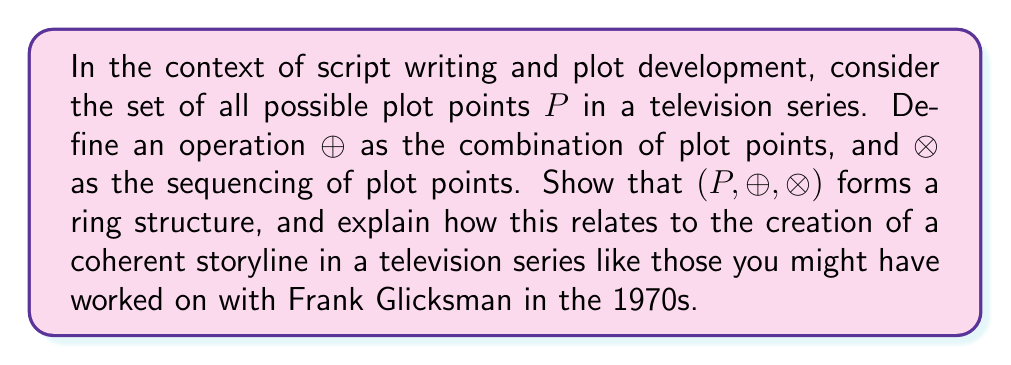What is the answer to this math problem? To show that $(P, \oplus, \otimes)$ forms a ring structure, we need to verify the following properties:

1. $(P, \oplus)$ is an abelian group:
   a) Closure: For any two plot points $a, b \in P$, $a \oplus b \in P$.
   b) Associativity: $(a \oplus b) \oplus c = a \oplus (b \oplus c)$ for all $a, b, c \in P$.
   c) Commutativity: $a \oplus b = b \oplus a$ for all $a, b \in P$.
   d) Identity: There exists an element $0 \in P$ such that $a \oplus 0 = a$ for all $a \in P$.
   e) Inverse: For each $a \in P$, there exists $-a \in P$ such that $a \oplus (-a) = 0$.

2. $(P, \otimes)$ is a monoid:
   a) Closure: For any two plot points $a, b \in P$, $a \otimes b \in P$.
   b) Associativity: $(a \otimes b) \otimes c = a \otimes (b \otimes c)$ for all $a, b, c \in P$.
   c) Identity: There exists an element $1 \in P$ such that $a \otimes 1 = 1 \otimes a = a$ for all $a \in P$.

3. Distributive laws:
   a) $a \otimes (b \oplus c) = (a \otimes b) \oplus (a \otimes c)$ for all $a, b, c \in P$.
   b) $(a \oplus b) \otimes c = (a \otimes c) \oplus (b \otimes c)$ for all $a, b, c \in P$.

In the context of script writing:

1. $(P, \oplus)$ represents the combination of plot points:
   a) Combining two plot points always results in a valid plot point.
   b) The order of combining plot points doesn't matter (commutativity).
   c) The "empty" plot point (0) represents no change to the story.
   d) Each plot point can be "undone" by its inverse.

2. $(P, \otimes)$ represents the sequencing of plot points:
   a) Sequencing two plot points always results in a valid plot sequence.
   b) The order of sequencing matters (non-commutativity).
   c) The "neutral" plot point (1) represents a plot point that doesn't affect the sequence.

3. The distributive laws show how combining and sequencing plot points interact.

This ring structure relates to creating a coherent storyline by providing a mathematical framework for organizing and manipulating plot points. It allows writers to combine, sequence, and rearrange plot elements while maintaining overall story consistency, much like how television series in the 1970s would develop complex, interconnected storylines over multiple episodes or seasons.
Answer: $(P, \oplus, \otimes)$ forms a ring structure, providing a mathematical framework for organizing and manipulating plot points in script writing and plot development. This structure allows for the consistent combination and sequencing of plot elements, facilitating the creation of coherent storylines in television series. 